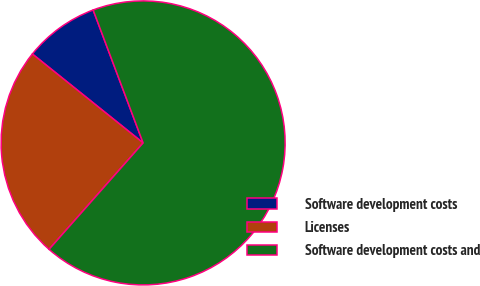Convert chart to OTSL. <chart><loc_0><loc_0><loc_500><loc_500><pie_chart><fcel>Software development costs<fcel>Licenses<fcel>Software development costs and<nl><fcel>8.51%<fcel>24.25%<fcel>67.24%<nl></chart> 